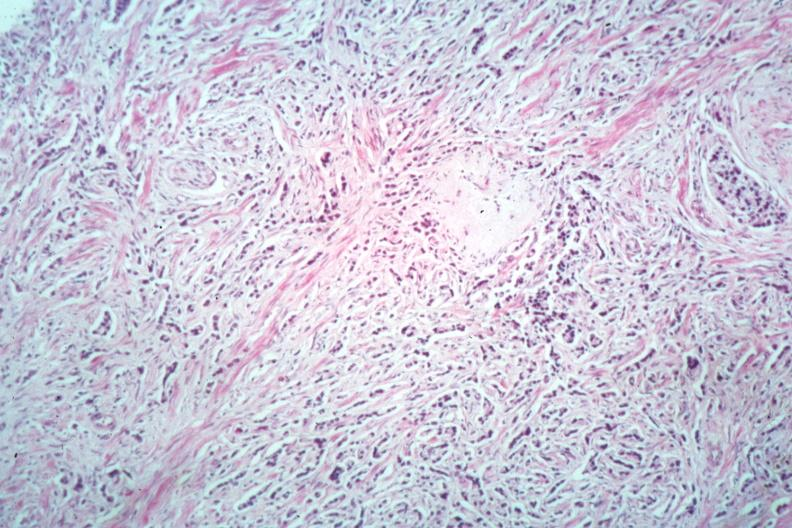s adenocarcinoma present?
Answer the question using a single word or phrase. Yes 